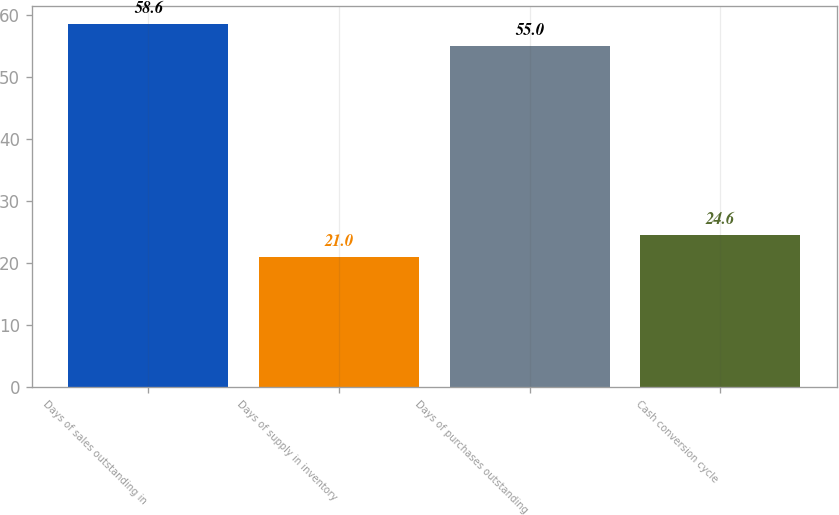Convert chart. <chart><loc_0><loc_0><loc_500><loc_500><bar_chart><fcel>Days of sales outstanding in<fcel>Days of supply in inventory<fcel>Days of purchases outstanding<fcel>Cash conversion cycle<nl><fcel>58.6<fcel>21<fcel>55<fcel>24.6<nl></chart> 